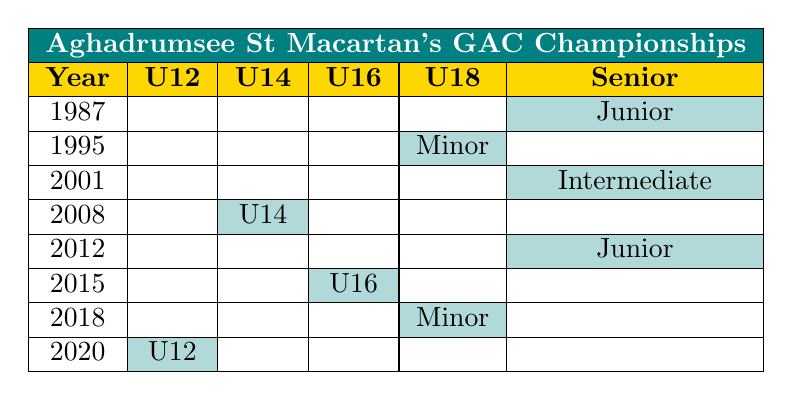What year did Aghadrumsee St Macartan's GAC win the Fermanagh U12 Football Championship? The Fermanagh U12 Football Championship was won in the year 2020 as indicated in the U12 column of the table.
Answer: 2020 How many championships did Aghadrumsee St Macartan's GAC win in the U18 age group? There are two championships listed under the U18 age group: one in 1995 (Minor) and one in 2018 (Minor).
Answer: 2 Which championship title was won in the year 2001? According to the table, the title won in 2001 was the Fermanagh Intermediate Football Championship, indicated in the Senior column.
Answer: Intermediate Is there a championship win in the U14 age group for Aghadrumsee St Macartan's GAC? Yes, the table shows a championship win in the U14 age group in 2008 for the Fermanagh U14 Football Championship.
Answer: Yes What is the total number of championships won in the Senior age group? The table indicates three championships in the Senior age group: 1987 (Junior), 2001 (Intermediate), and 2012 (Junior). So, the total is 3.
Answer: 3 Which age group has the least number of championship wins? By reviewing the table, the U12 age group has only one championship win in 2020, which is fewer than any other age group.
Answer: U12 In how many different years did Aghadrumsee St Macartan's GAC win the Fermanagh Junior Football Championship? The title was won in two different years: 1987 and 2012, as shown in the Senior column.
Answer: 2 What is the most recent championship title won by Aghadrumsee St Macartan's GAC? The most recent championship title won is the Fermanagh U12 Football Championship in 2020, which is the latest entry in the table.
Answer: U12 Football Championship Which age group had the first championship win recorded in the table? The first championship win recorded in the table is for the Senior age group in 1987 for the Fermanagh Junior Football Championship.
Answer: Senior Are there any championships won in consecutive years? No, the table does not show any championships winning for Aghadrumsee St Macartan's GAC in consecutive years; there are gaps between all winning years.
Answer: No 